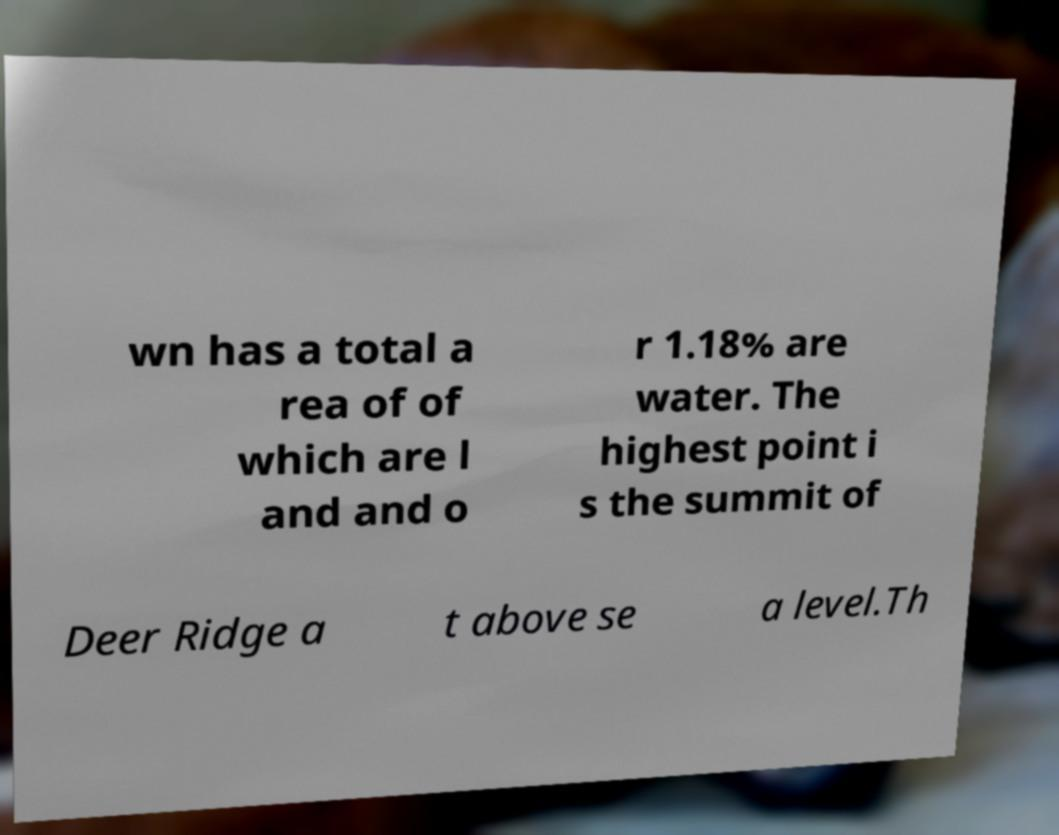Could you extract and type out the text from this image? wn has a total a rea of of which are l and and o r 1.18% are water. The highest point i s the summit of Deer Ridge a t above se a level.Th 